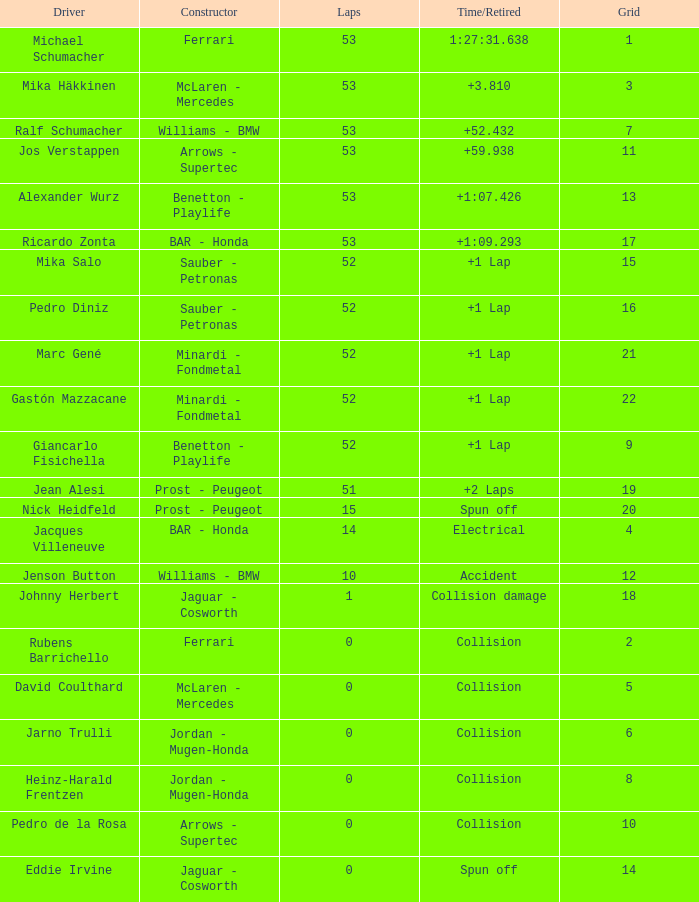What is the count of laps ricardo zonta had? 53.0. 